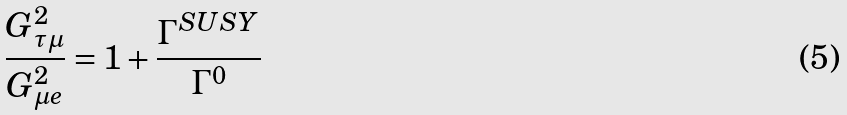<formula> <loc_0><loc_0><loc_500><loc_500>\frac { G ^ { 2 } _ { \tau \mu } } { G ^ { 2 } _ { \mu e } } = 1 + \frac { \Gamma ^ { S U S Y } } { \Gamma ^ { 0 } }</formula> 